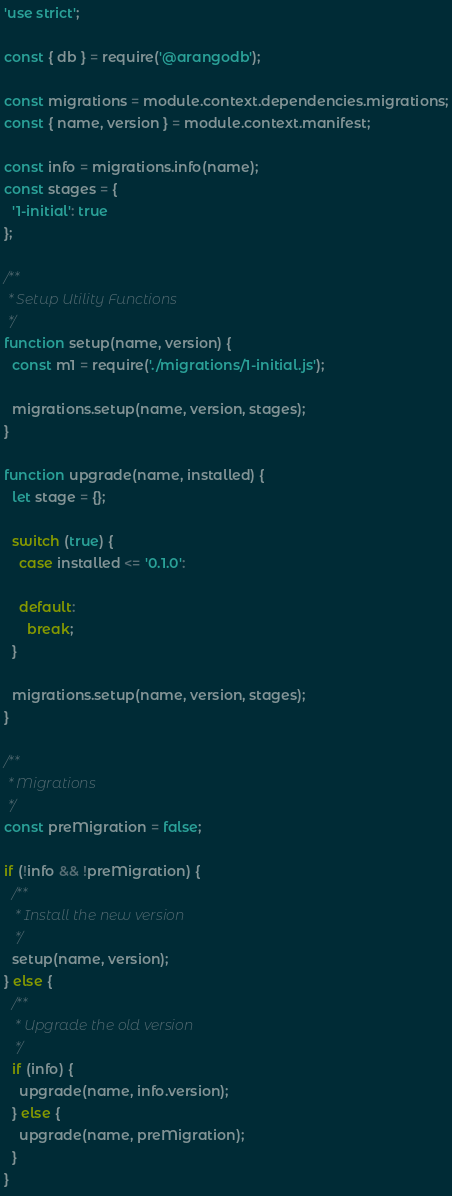Convert code to text. <code><loc_0><loc_0><loc_500><loc_500><_JavaScript_>'use strict';

const { db } = require('@arangodb');

const migrations = module.context.dependencies.migrations;
const { name, version } = module.context.manifest;

const info = migrations.info(name);
const stages = {
  '1-initial': true
};

/**
 * Setup Utility Functions
 */
function setup(name, version) {
  const m1 = require('./migrations/1-initial.js');

  migrations.setup(name, version, stages);
}

function upgrade(name, installed) {
  let stage = {};

  switch (true) {
    case installed <= '0.1.0':

    default:
      break;
  }

  migrations.setup(name, version, stages);
}

/**
 * Migrations
 */
const preMigration = false;

if (!info && !preMigration) {
  /**
   * Install the new version
   */
  setup(name, version);
} else {
  /**
   * Upgrade the old version
   */
  if (info) {
    upgrade(name, info.version);
  } else {
    upgrade(name, preMigration);
  }
}
</code> 